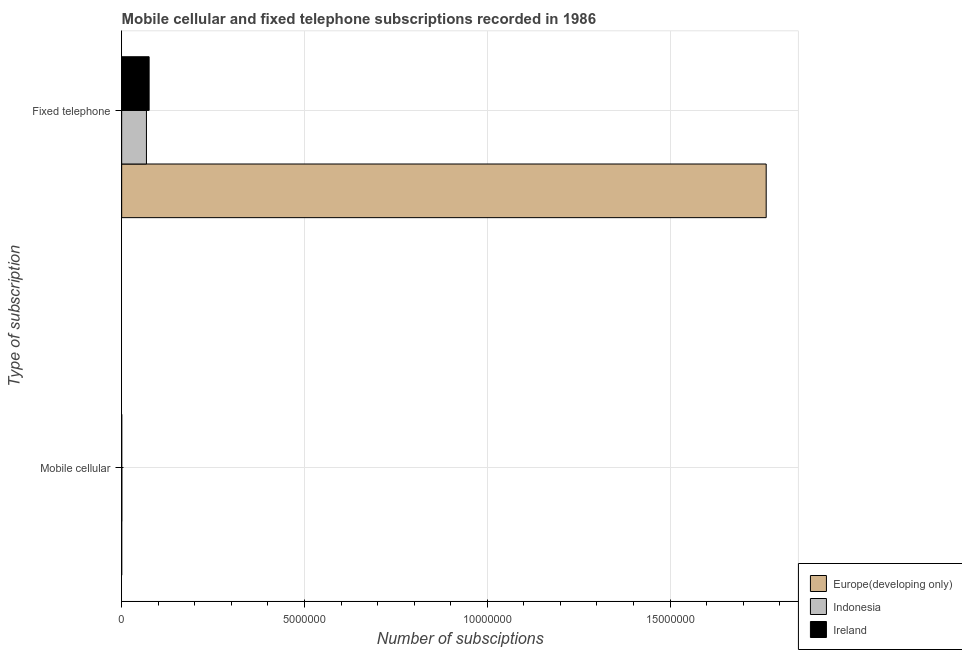How many different coloured bars are there?
Your answer should be compact. 3. Are the number of bars per tick equal to the number of legend labels?
Offer a very short reply. Yes. Are the number of bars on each tick of the Y-axis equal?
Your answer should be very brief. Yes. How many bars are there on the 2nd tick from the top?
Ensure brevity in your answer.  3. What is the label of the 2nd group of bars from the top?
Give a very brief answer. Mobile cellular. What is the number of fixed telephone subscriptions in Indonesia?
Your answer should be compact. 6.77e+05. Across all countries, what is the maximum number of mobile cellular subscriptions?
Offer a very short reply. 4531. Across all countries, what is the minimum number of fixed telephone subscriptions?
Your answer should be compact. 6.77e+05. What is the total number of mobile cellular subscriptions in the graph?
Provide a succinct answer. 6396. What is the difference between the number of fixed telephone subscriptions in Ireland and that in Indonesia?
Your answer should be compact. 7.35e+04. What is the difference between the number of fixed telephone subscriptions in Europe(developing only) and the number of mobile cellular subscriptions in Indonesia?
Offer a very short reply. 1.76e+07. What is the average number of mobile cellular subscriptions per country?
Your answer should be very brief. 2132. What is the difference between the number of mobile cellular subscriptions and number of fixed telephone subscriptions in Ireland?
Keep it short and to the point. -7.49e+05. What is the ratio of the number of fixed telephone subscriptions in Ireland to that in Indonesia?
Provide a short and direct response. 1.11. What does the 3rd bar from the top in Fixed telephone represents?
Provide a succinct answer. Europe(developing only). What does the 2nd bar from the bottom in Fixed telephone represents?
Provide a short and direct response. Indonesia. How many countries are there in the graph?
Your answer should be very brief. 3. What is the difference between two consecutive major ticks on the X-axis?
Keep it short and to the point. 5.00e+06. Are the values on the major ticks of X-axis written in scientific E-notation?
Provide a short and direct response. No. Does the graph contain grids?
Ensure brevity in your answer.  Yes. How many legend labels are there?
Offer a very short reply. 3. What is the title of the graph?
Your response must be concise. Mobile cellular and fixed telephone subscriptions recorded in 1986. What is the label or title of the X-axis?
Give a very brief answer. Number of subsciptions. What is the label or title of the Y-axis?
Offer a very short reply. Type of subscription. What is the Number of subsciptions in Europe(developing only) in Mobile cellular?
Provide a short and direct response. 365. What is the Number of subsciptions in Indonesia in Mobile cellular?
Your answer should be very brief. 4531. What is the Number of subsciptions in Ireland in Mobile cellular?
Provide a short and direct response. 1500. What is the Number of subsciptions in Europe(developing only) in Fixed telephone?
Provide a short and direct response. 1.76e+07. What is the Number of subsciptions of Indonesia in Fixed telephone?
Your response must be concise. 6.77e+05. What is the Number of subsciptions in Ireland in Fixed telephone?
Your response must be concise. 7.51e+05. Across all Type of subscription, what is the maximum Number of subsciptions of Europe(developing only)?
Your answer should be very brief. 1.76e+07. Across all Type of subscription, what is the maximum Number of subsciptions in Indonesia?
Keep it short and to the point. 6.77e+05. Across all Type of subscription, what is the maximum Number of subsciptions of Ireland?
Offer a very short reply. 7.51e+05. Across all Type of subscription, what is the minimum Number of subsciptions in Europe(developing only)?
Provide a succinct answer. 365. Across all Type of subscription, what is the minimum Number of subsciptions of Indonesia?
Your answer should be compact. 4531. Across all Type of subscription, what is the minimum Number of subsciptions in Ireland?
Keep it short and to the point. 1500. What is the total Number of subsciptions of Europe(developing only) in the graph?
Provide a succinct answer. 1.76e+07. What is the total Number of subsciptions of Indonesia in the graph?
Provide a succinct answer. 6.82e+05. What is the total Number of subsciptions in Ireland in the graph?
Ensure brevity in your answer.  7.52e+05. What is the difference between the Number of subsciptions in Europe(developing only) in Mobile cellular and that in Fixed telephone?
Give a very brief answer. -1.76e+07. What is the difference between the Number of subsciptions in Indonesia in Mobile cellular and that in Fixed telephone?
Keep it short and to the point. -6.73e+05. What is the difference between the Number of subsciptions in Ireland in Mobile cellular and that in Fixed telephone?
Your answer should be compact. -7.49e+05. What is the difference between the Number of subsciptions of Europe(developing only) in Mobile cellular and the Number of subsciptions of Indonesia in Fixed telephone?
Make the answer very short. -6.77e+05. What is the difference between the Number of subsciptions of Europe(developing only) in Mobile cellular and the Number of subsciptions of Ireland in Fixed telephone?
Offer a very short reply. -7.50e+05. What is the difference between the Number of subsciptions in Indonesia in Mobile cellular and the Number of subsciptions in Ireland in Fixed telephone?
Keep it short and to the point. -7.46e+05. What is the average Number of subsciptions of Europe(developing only) per Type of subscription?
Make the answer very short. 8.82e+06. What is the average Number of subsciptions in Indonesia per Type of subscription?
Ensure brevity in your answer.  3.41e+05. What is the average Number of subsciptions of Ireland per Type of subscription?
Offer a terse response. 3.76e+05. What is the difference between the Number of subsciptions of Europe(developing only) and Number of subsciptions of Indonesia in Mobile cellular?
Your answer should be very brief. -4166. What is the difference between the Number of subsciptions in Europe(developing only) and Number of subsciptions in Ireland in Mobile cellular?
Provide a succinct answer. -1135. What is the difference between the Number of subsciptions of Indonesia and Number of subsciptions of Ireland in Mobile cellular?
Provide a succinct answer. 3031. What is the difference between the Number of subsciptions in Europe(developing only) and Number of subsciptions in Indonesia in Fixed telephone?
Provide a short and direct response. 1.70e+07. What is the difference between the Number of subsciptions of Europe(developing only) and Number of subsciptions of Ireland in Fixed telephone?
Your answer should be very brief. 1.69e+07. What is the difference between the Number of subsciptions in Indonesia and Number of subsciptions in Ireland in Fixed telephone?
Give a very brief answer. -7.35e+04. What is the ratio of the Number of subsciptions in Europe(developing only) in Mobile cellular to that in Fixed telephone?
Ensure brevity in your answer.  0. What is the ratio of the Number of subsciptions in Indonesia in Mobile cellular to that in Fixed telephone?
Keep it short and to the point. 0.01. What is the ratio of the Number of subsciptions in Ireland in Mobile cellular to that in Fixed telephone?
Your answer should be compact. 0. What is the difference between the highest and the second highest Number of subsciptions in Europe(developing only)?
Give a very brief answer. 1.76e+07. What is the difference between the highest and the second highest Number of subsciptions in Indonesia?
Provide a succinct answer. 6.73e+05. What is the difference between the highest and the second highest Number of subsciptions of Ireland?
Provide a short and direct response. 7.49e+05. What is the difference between the highest and the lowest Number of subsciptions of Europe(developing only)?
Offer a terse response. 1.76e+07. What is the difference between the highest and the lowest Number of subsciptions of Indonesia?
Offer a very short reply. 6.73e+05. What is the difference between the highest and the lowest Number of subsciptions of Ireland?
Your answer should be very brief. 7.49e+05. 